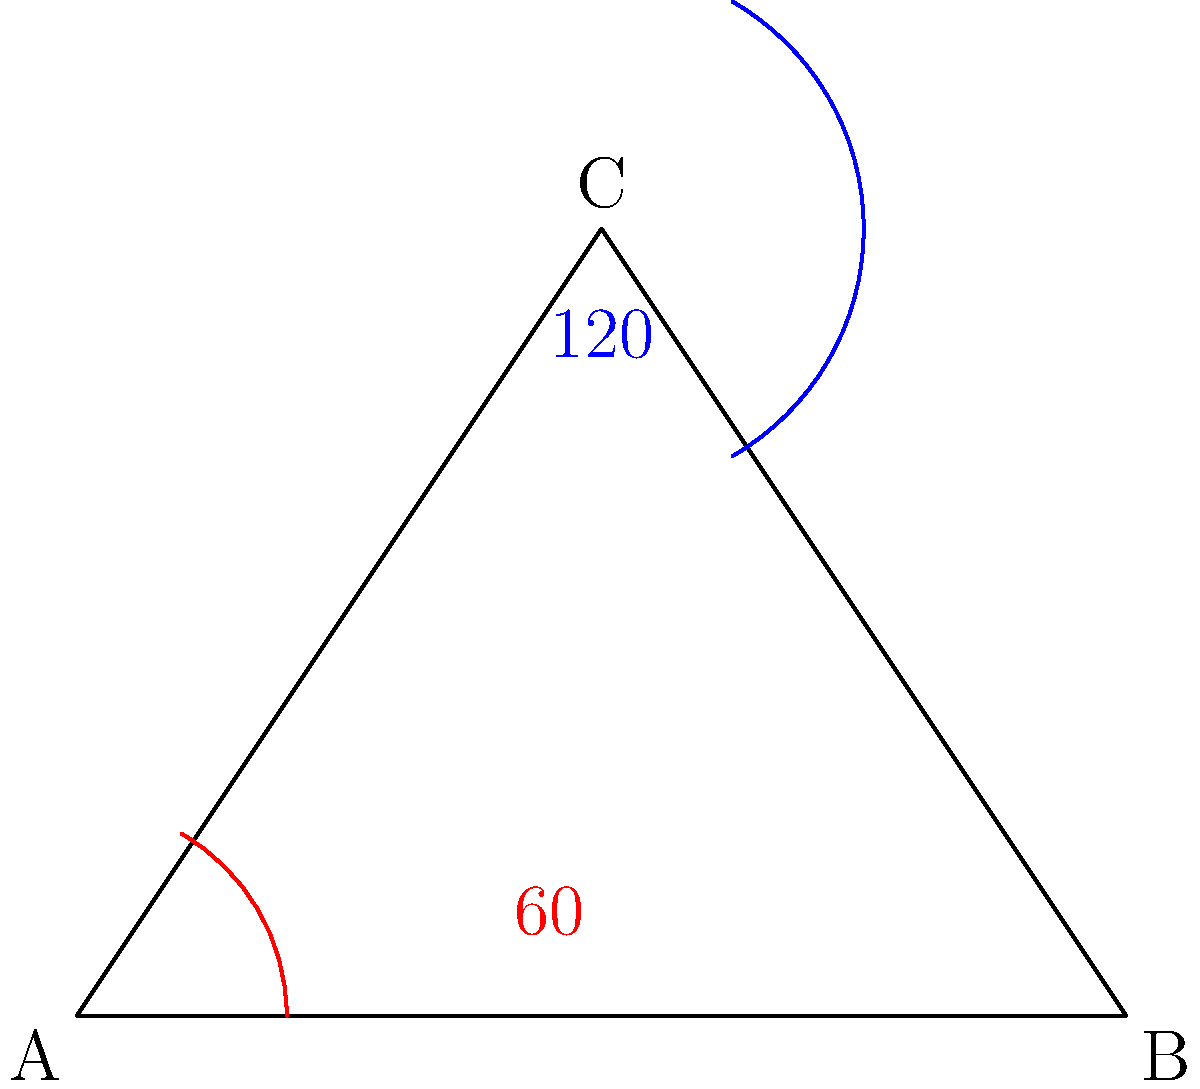In traditional Slovenian architecture, the roof angle of a typical rural house in the Litija region is often 60°. If the angle at the peak of the roof (angle C in the diagram) is 120°, what is the measure of angle B? Let's approach this step-by-step:

1) In any triangle, the sum of all interior angles is always 180°.

2) We are given two angles in this triangle:
   - Angle A (the roof angle) = 60°
   - Angle C (the peak angle) = 120°

3) Let's call the measure of angle B as x°.

4) We can set up an equation based on the fact that the sum of all angles in a triangle is 180°:

   $$60° + 120° + x° = 180°$$

5) Simplify:
   $$180° + x° = 180°$$

6) Subtract 180° from both sides:
   $$x° = 0°$$

Therefore, angle B measures 0°.

This result shows that the triangle is degenerate (not a proper triangle), as one of its angles is 0°. In practical architecture, this would mean the roof is essentially flat on one side, which is not typical. This example serves to illustrate the mathematical principle, but in real Slovenian rural architecture, the angles would be adjusted to create a functional roof structure.
Answer: 0° 